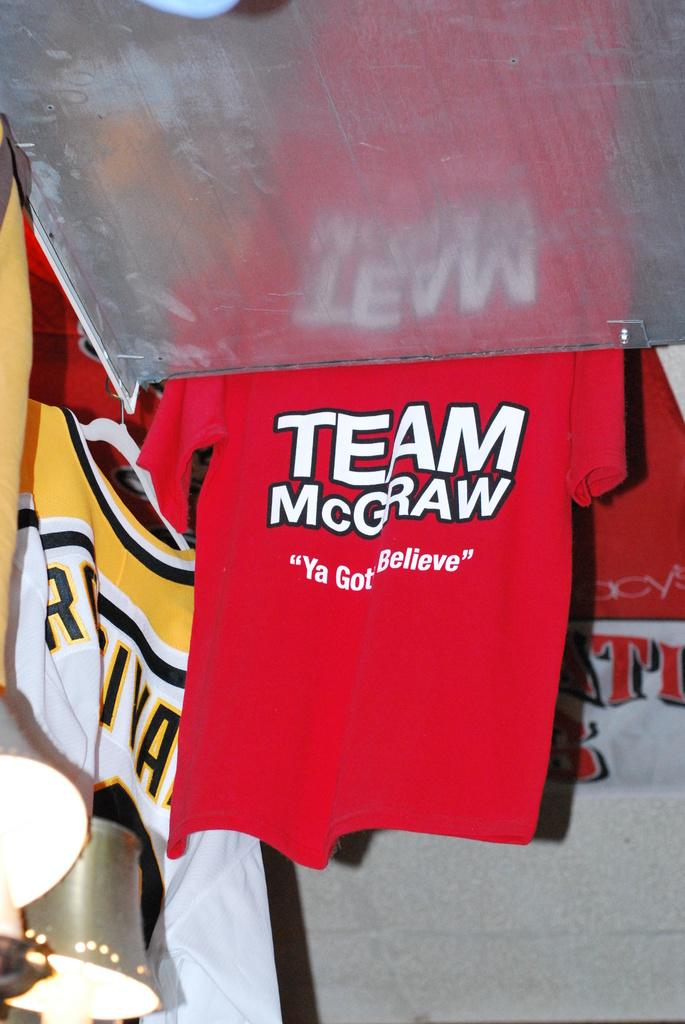<image>
Create a compact narrative representing the image presented. a shirt that has the word Team McGraw on it 